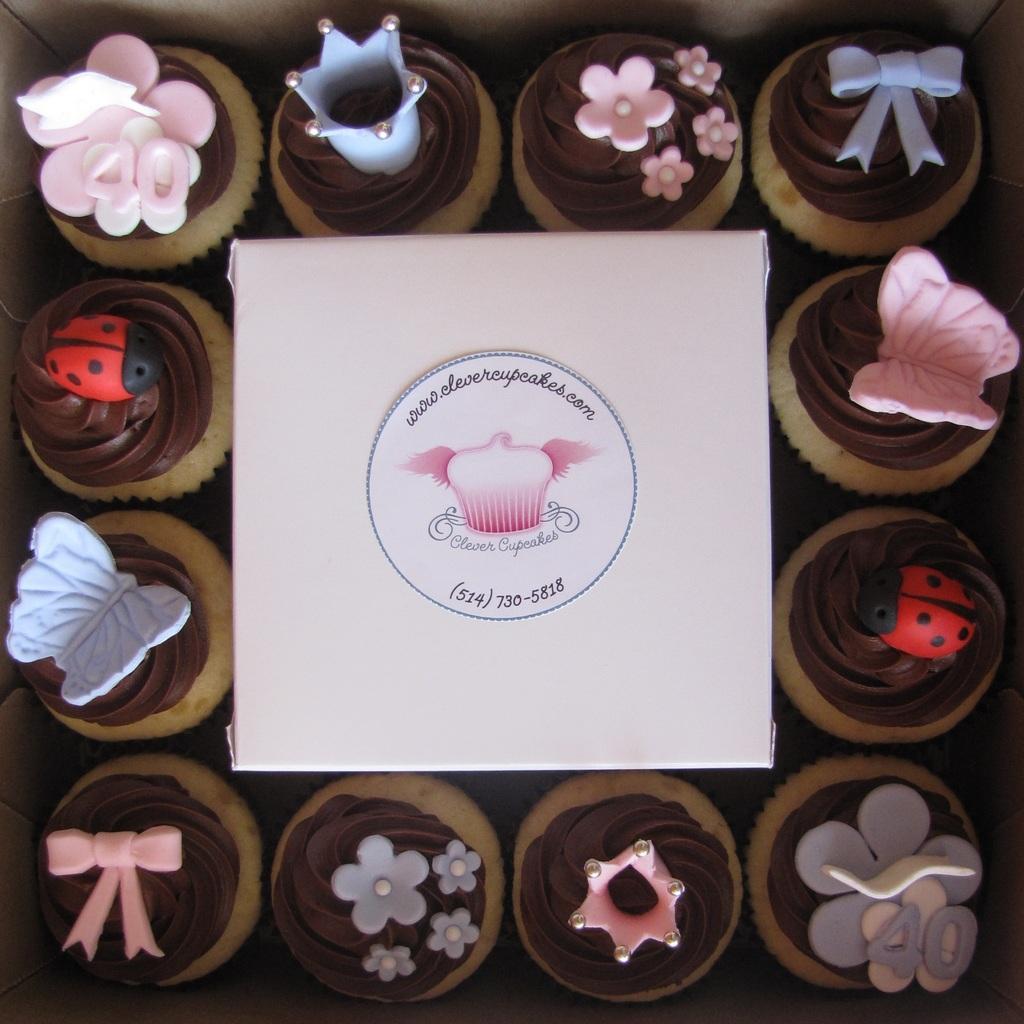Could you give a brief overview of what you see in this image? In this picture we observe many cupcakes which are designed beautifully and in the middle we observe a poster which is named as CLEVER CUPCAKES. 